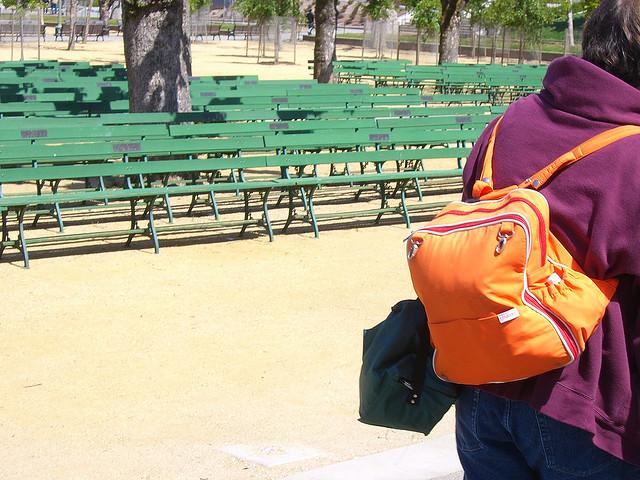What color is the backpack?
Short answer required. Orange. Is anybody sitting on the benches?
Write a very short answer. No. What color are the benches?
Give a very brief answer. Green. 